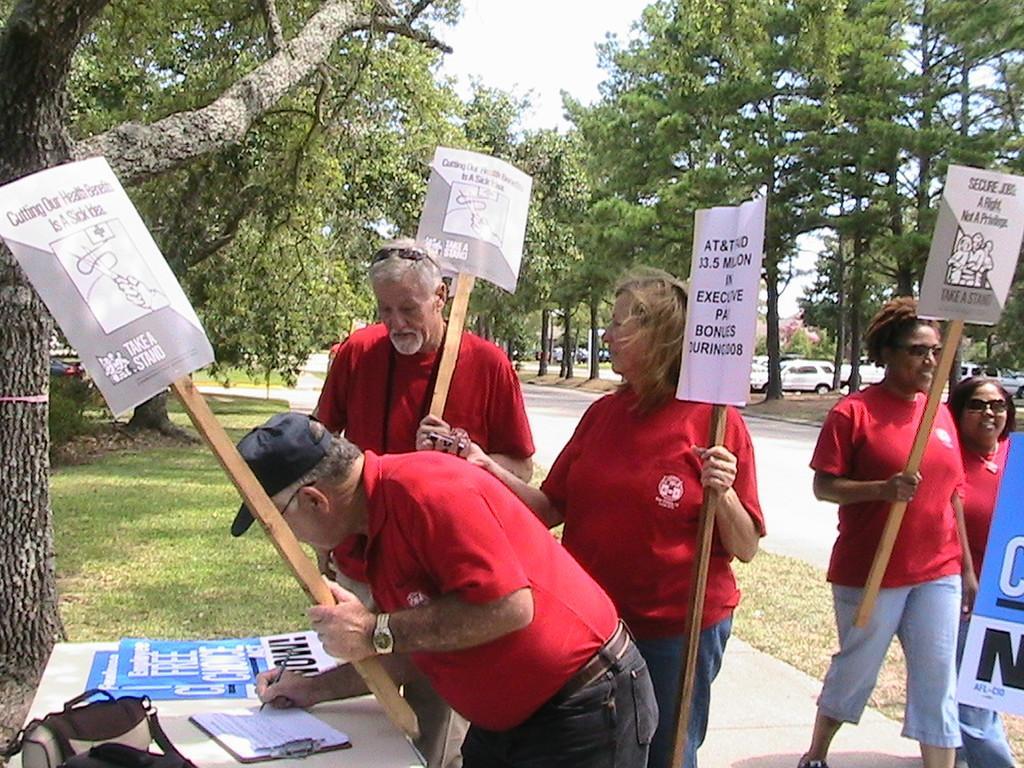Could you give a brief overview of what you see in this image? In this image we can see a group of people standing on the ground holding some boards with text on it. In that a man is holding a pen standing near a table containing a pad, some papers and a bag placed on it. On the backside we can see the bark of a tree, a group of trees, grass, the pathway and the sky which looks cloudy. 